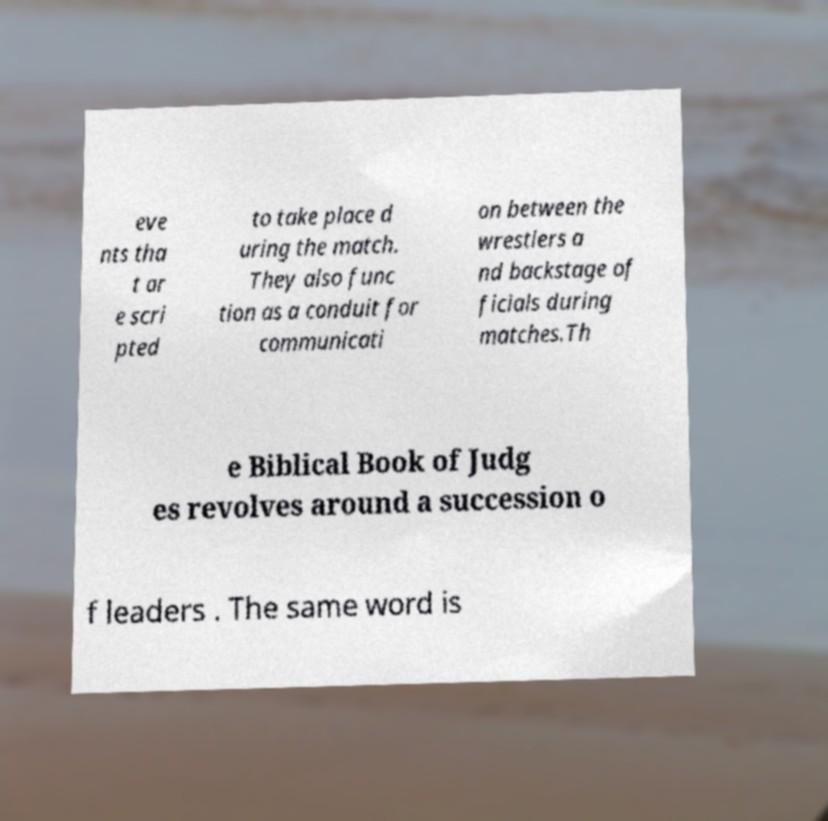Can you read and provide the text displayed in the image?This photo seems to have some interesting text. Can you extract and type it out for me? eve nts tha t ar e scri pted to take place d uring the match. They also func tion as a conduit for communicati on between the wrestlers a nd backstage of ficials during matches.Th e Biblical Book of Judg es revolves around a succession o f leaders . The same word is 